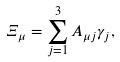<formula> <loc_0><loc_0><loc_500><loc_500>\Xi _ { \mu } = \sum _ { j = 1 } ^ { 3 } A _ { \mu j } \gamma _ { j } ,</formula> 